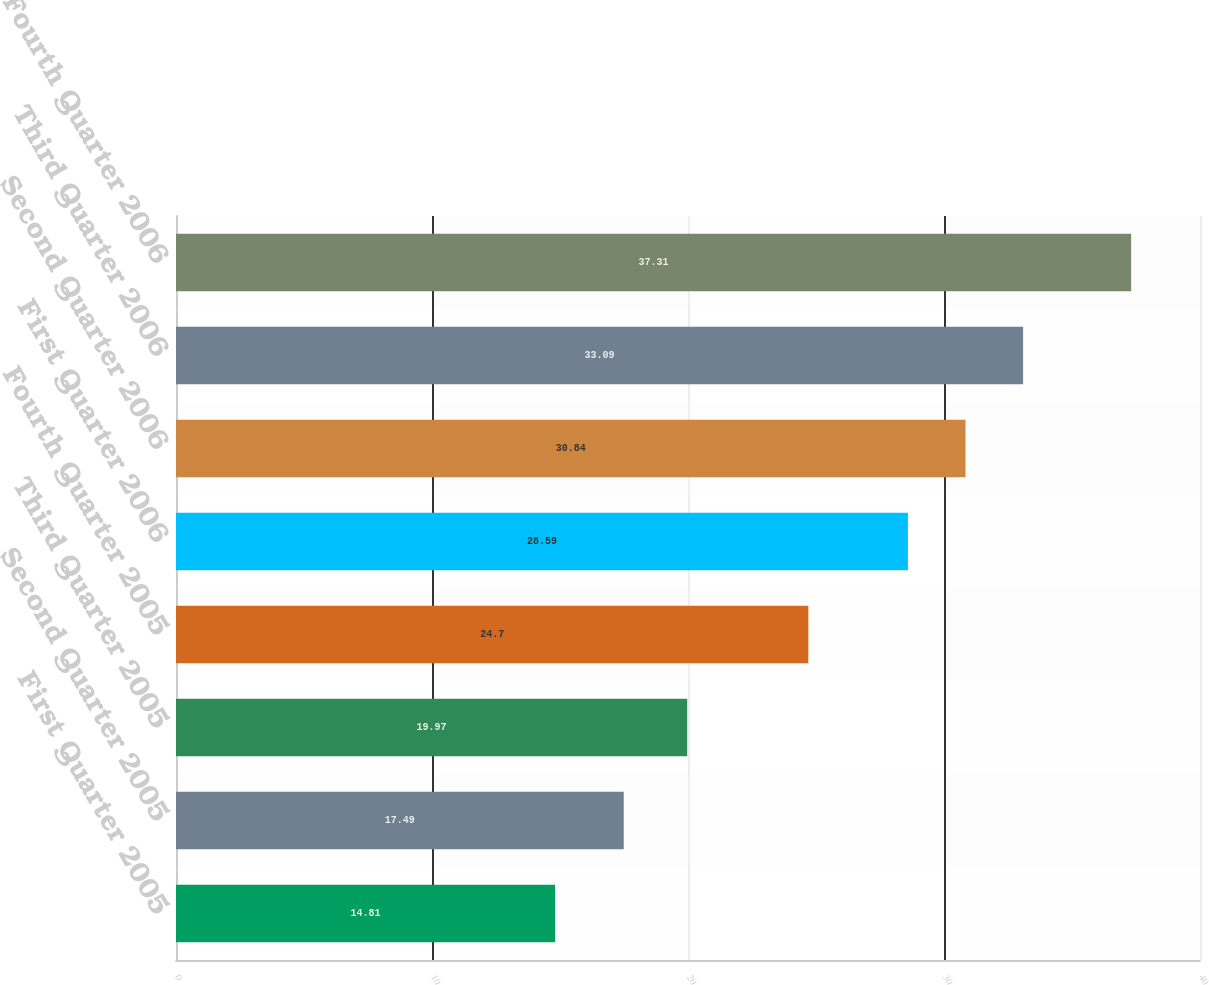<chart> <loc_0><loc_0><loc_500><loc_500><bar_chart><fcel>First Quarter 2005<fcel>Second Quarter 2005<fcel>Third Quarter 2005<fcel>Fourth Quarter 2005<fcel>First Quarter 2006<fcel>Second Quarter 2006<fcel>Third Quarter 2006<fcel>Fourth Quarter 2006<nl><fcel>14.81<fcel>17.49<fcel>19.97<fcel>24.7<fcel>28.59<fcel>30.84<fcel>33.09<fcel>37.31<nl></chart> 